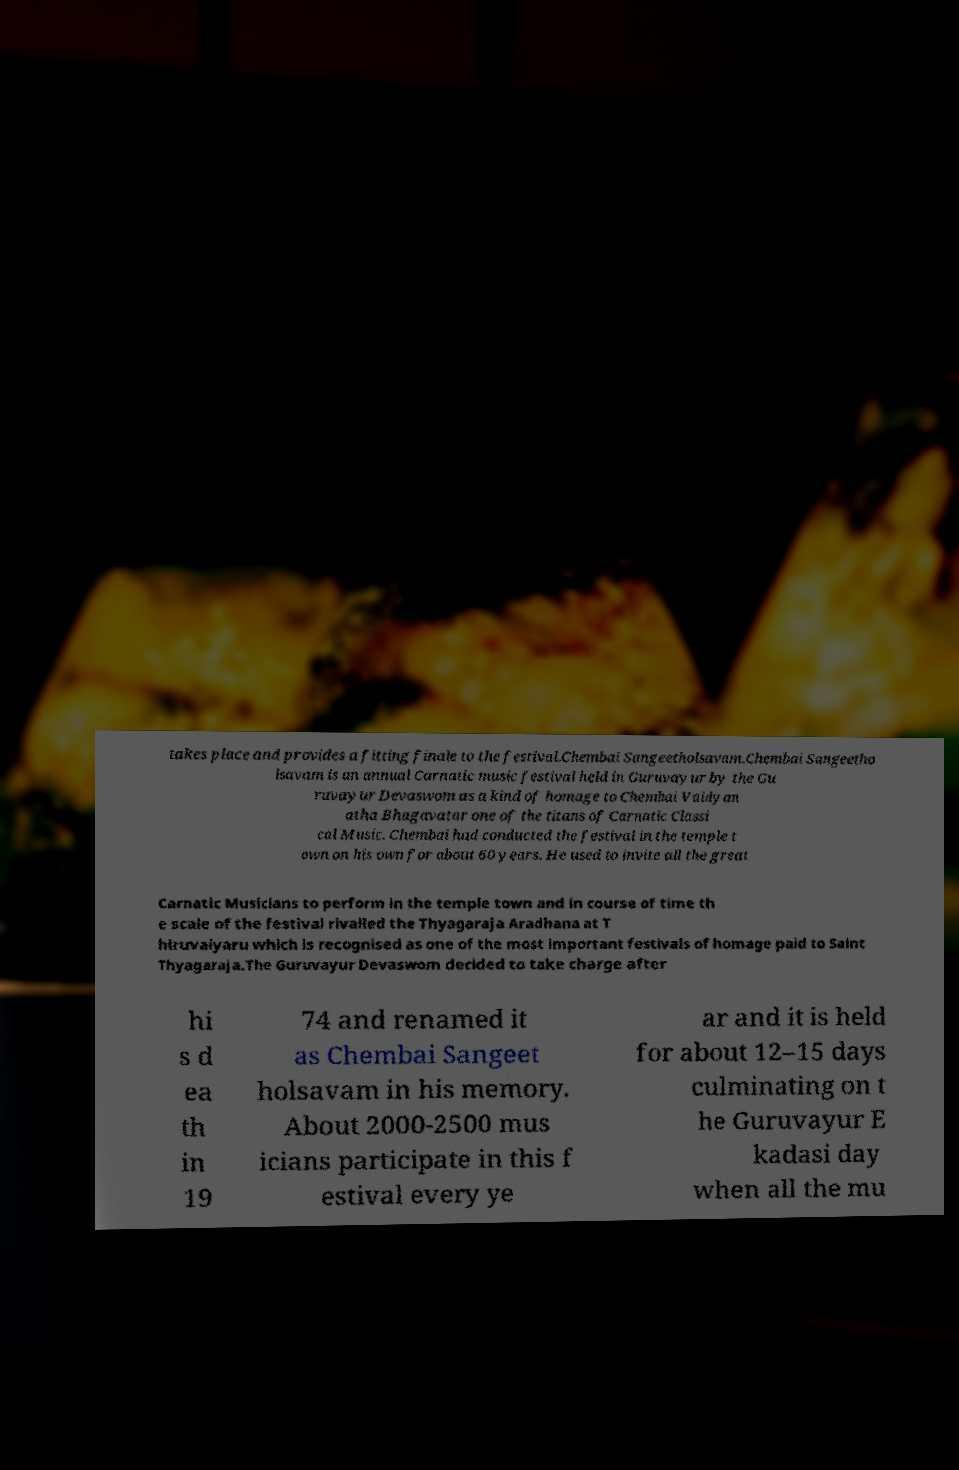For documentation purposes, I need the text within this image transcribed. Could you provide that? takes place and provides a fitting finale to the festival.Chembai Sangeetholsavam.Chembai Sangeetho lsavam is an annual Carnatic music festival held in Guruvayur by the Gu ruvayur Devaswom as a kind of homage to Chembai Vaidyan atha Bhagavatar one of the titans of Carnatic Classi cal Music. Chembai had conducted the festival in the temple t own on his own for about 60 years. He used to invite all the great Carnatic Musicians to perform in the temple town and in course of time th e scale of the festival rivalled the Thyagaraja Aradhana at T hiruvaiyaru which is recognised as one of the most important festivals of homage paid to Saint Thyagaraja.The Guruvayur Devaswom decided to take charge after hi s d ea th in 19 74 and renamed it as Chembai Sangeet holsavam in his memory. About 2000-2500 mus icians participate in this f estival every ye ar and it is held for about 12–15 days culminating on t he Guruvayur E kadasi day when all the mu 